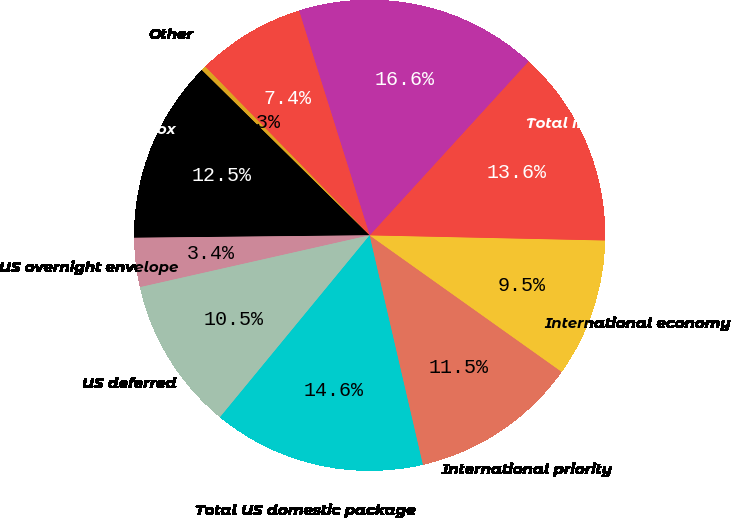<chart> <loc_0><loc_0><loc_500><loc_500><pie_chart><fcel>US overnight box<fcel>US overnight envelope<fcel>US deferred<fcel>Total US domestic package<fcel>International priority<fcel>International economy<fcel>Total international export<fcel>Total package revenue<fcel>US<fcel>Other<nl><fcel>12.55%<fcel>3.37%<fcel>10.51%<fcel>14.59%<fcel>11.53%<fcel>9.49%<fcel>13.57%<fcel>16.63%<fcel>7.45%<fcel>0.32%<nl></chart> 